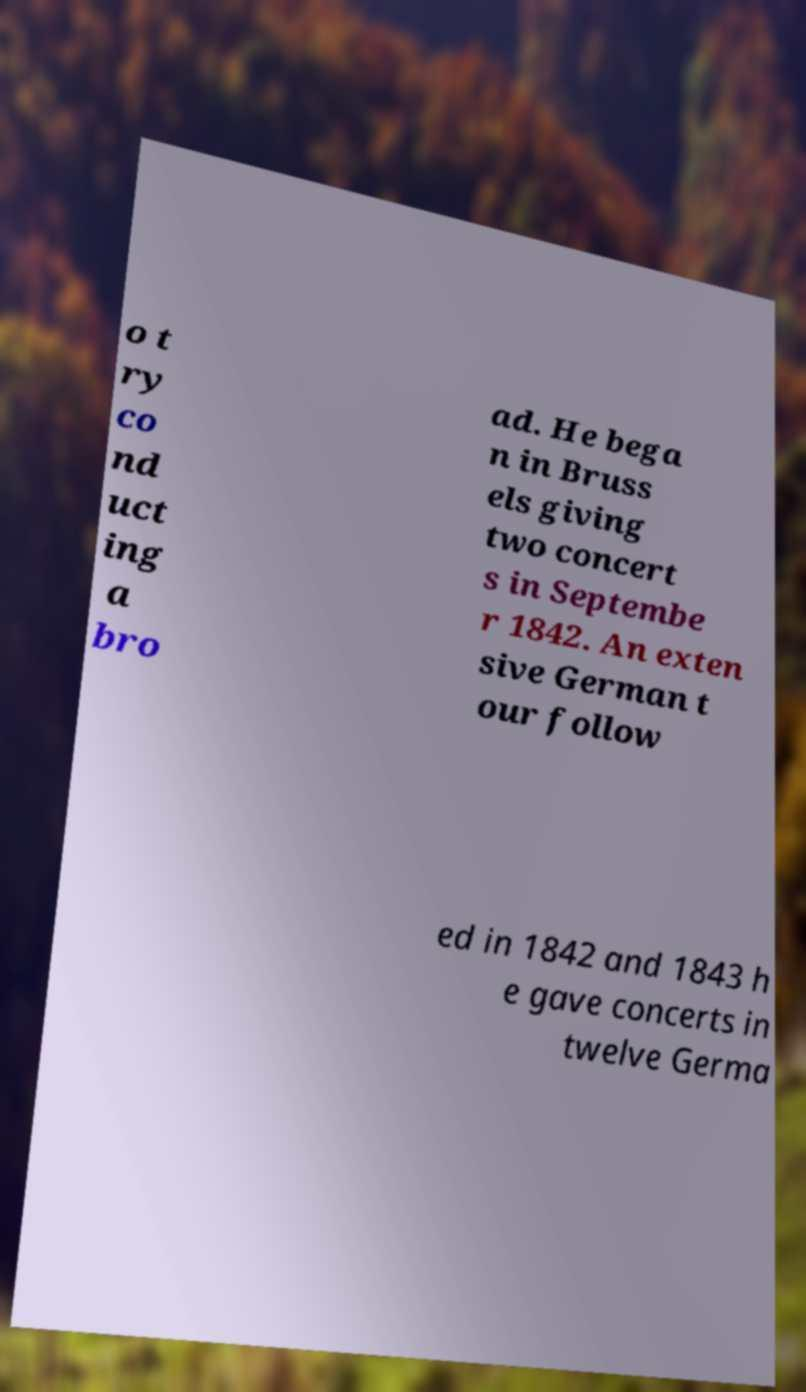Could you extract and type out the text from this image? o t ry co nd uct ing a bro ad. He bega n in Bruss els giving two concert s in Septembe r 1842. An exten sive German t our follow ed in 1842 and 1843 h e gave concerts in twelve Germa 